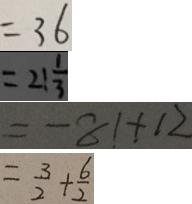<formula> <loc_0><loc_0><loc_500><loc_500>= 3 6 
 = 2 1 \frac { 1 } { 3 } 
 = - 8 1 + 1 2 
 = \frac { 3 } { 2 } + \frac { 6 } { 2 }</formula> 